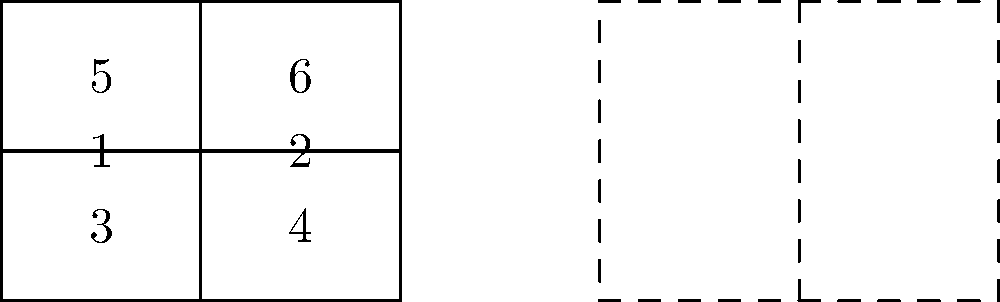You are designing a patient information brochure about assisted reproductive technology for your community. The brochure will be folded as shown in the diagram. If the brochure is folded in half vertically and then in half horizontally, which numbered sections will be visible on the outside when fully folded? To solve this problem, let's follow these steps:

1. Visualize the vertical fold:
   - The brochure will be folded along the vertical line E-G.
   - This will bring sections 2, 4, and 6 behind sections 1, 3, and 5.

2. Visualize the horizontal fold:
   - After the vertical fold, the brochure will be folded along the horizontal line H-F.
   - This will bring sections 3 and 4 (which is now behind 3) to the top of sections 1 and 2 (which is now behind 1).

3. Identify the visible sections:
   - After both folds, section 3 will be on top and fully visible.
   - Section 1 will be visible on the bottom.
   - The back of the folded brochure will show section 6, which was originally on the right side of the unfolded brochure.

Therefore, the sections that will be visible on the outside when fully folded are 1, 3, and 6.
Answer: 1, 3, and 6 